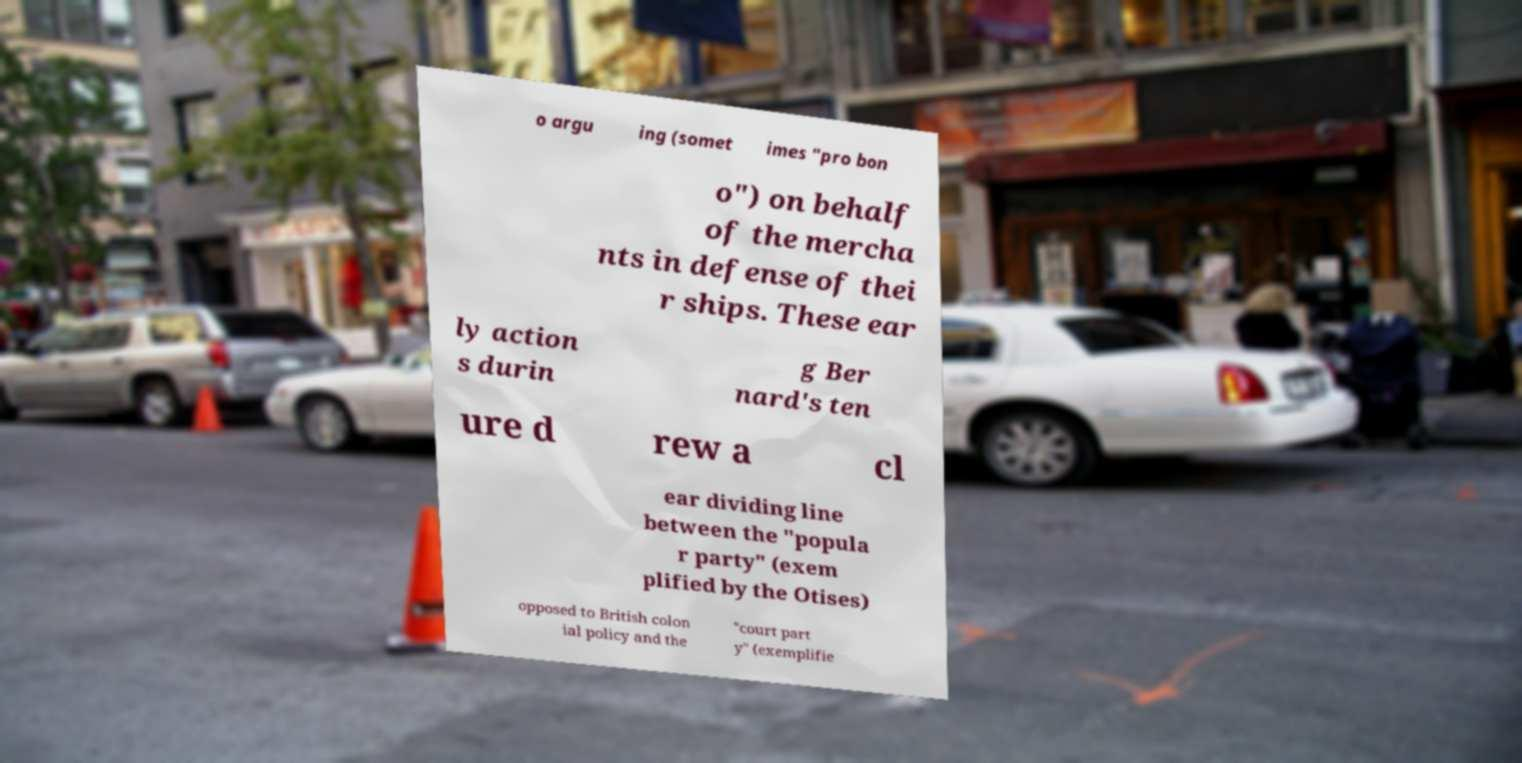Please identify and transcribe the text found in this image. o argu ing (somet imes "pro bon o") on behalf of the mercha nts in defense of thei r ships. These ear ly action s durin g Ber nard's ten ure d rew a cl ear dividing line between the "popula r party" (exem plified by the Otises) opposed to British colon ial policy and the "court part y" (exemplifie 